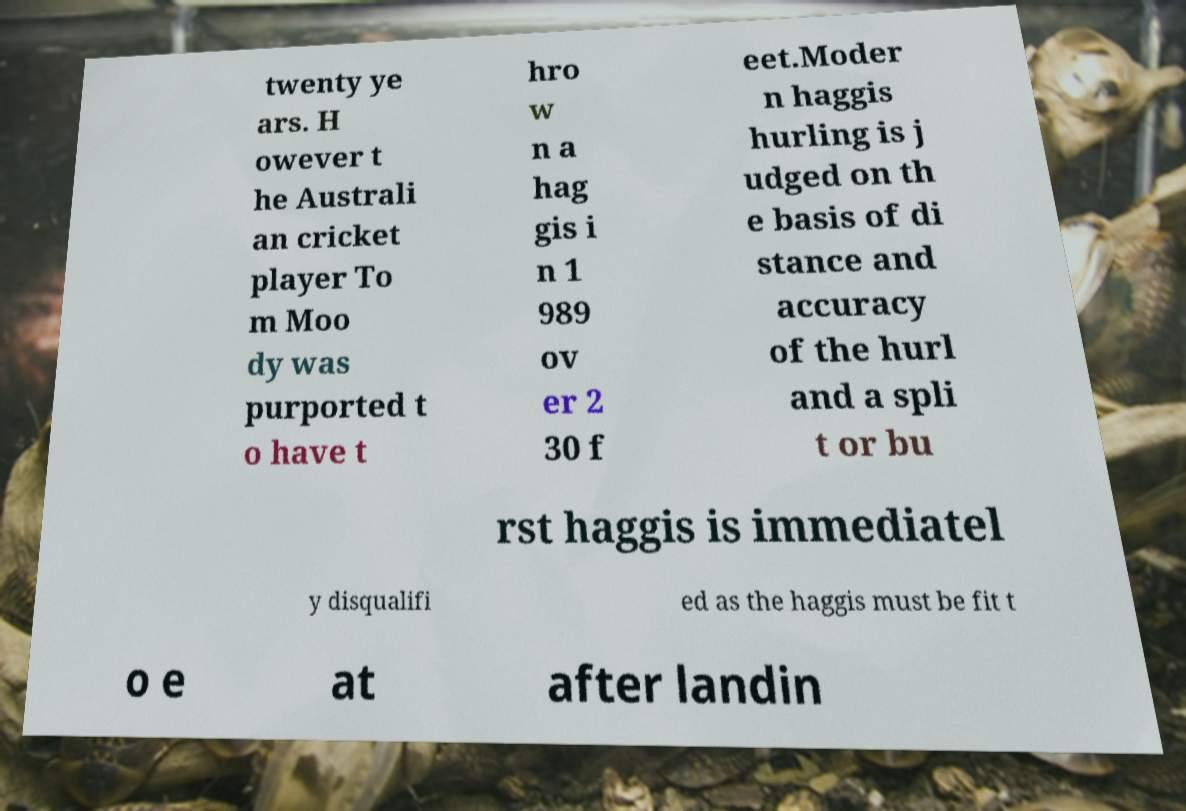Can you read and provide the text displayed in the image?This photo seems to have some interesting text. Can you extract and type it out for me? twenty ye ars. H owever t he Australi an cricket player To m Moo dy was purported t o have t hro w n a hag gis i n 1 989 ov er 2 30 f eet.Moder n haggis hurling is j udged on th e basis of di stance and accuracy of the hurl and a spli t or bu rst haggis is immediatel y disqualifi ed as the haggis must be fit t o e at after landin 